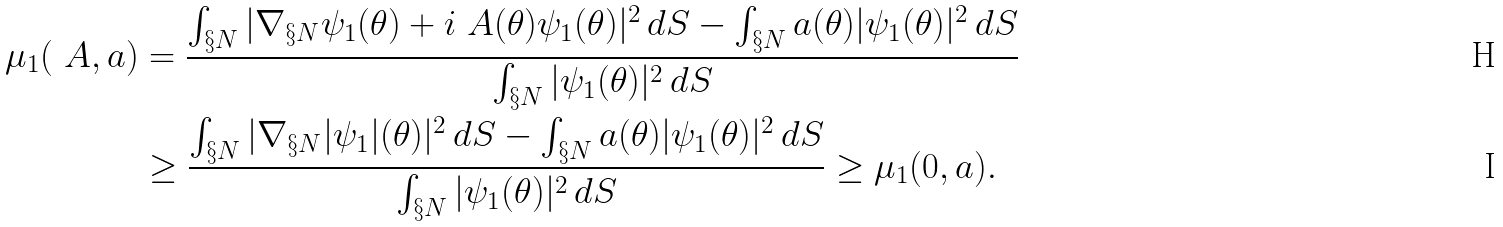<formula> <loc_0><loc_0><loc_500><loc_500>\mu _ { 1 } ( \ A , a ) & = \frac { \int _ { \S N } | \nabla _ { \S N } \psi _ { 1 } ( \theta ) + i \ A ( \theta ) \psi _ { 1 } ( \theta ) | ^ { 2 } \, d S - \int _ { \S N } a ( \theta ) | \psi _ { 1 } ( \theta ) | ^ { 2 } \, d S } { \int _ { \S N } | \psi _ { 1 } ( \theta ) | ^ { 2 } \, d S } \\ & \geq \frac { \int _ { \S N } | \nabla _ { \S N } | \psi _ { 1 } | ( \theta ) | ^ { 2 } \, d S - \int _ { \S N } a ( \theta ) | \psi _ { 1 } ( \theta ) | ^ { 2 } \, d S } { \int _ { \S N } | \psi _ { 1 } ( \theta ) | ^ { 2 } \, d S } \geq \mu _ { 1 } ( 0 , a ) .</formula> 